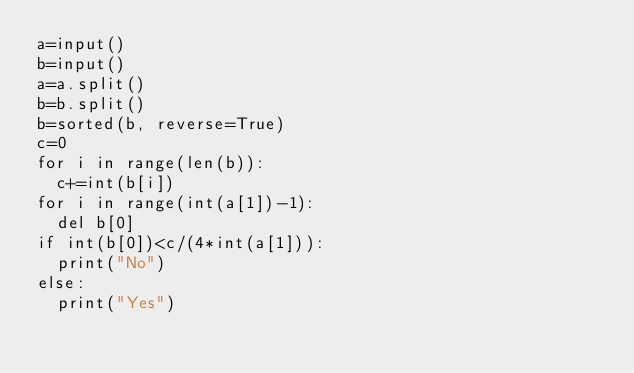Convert code to text. <code><loc_0><loc_0><loc_500><loc_500><_Python_>a=input()
b=input()
a=a.split()
b=b.split()
b=sorted(b, reverse=True)
c=0
for i in range(len(b)):
  c+=int(b[i])
for i in range(int(a[1])-1):
  del b[0]
if int(b[0])<c/(4*int(a[1])):
  print("No")
else:
  print("Yes")</code> 